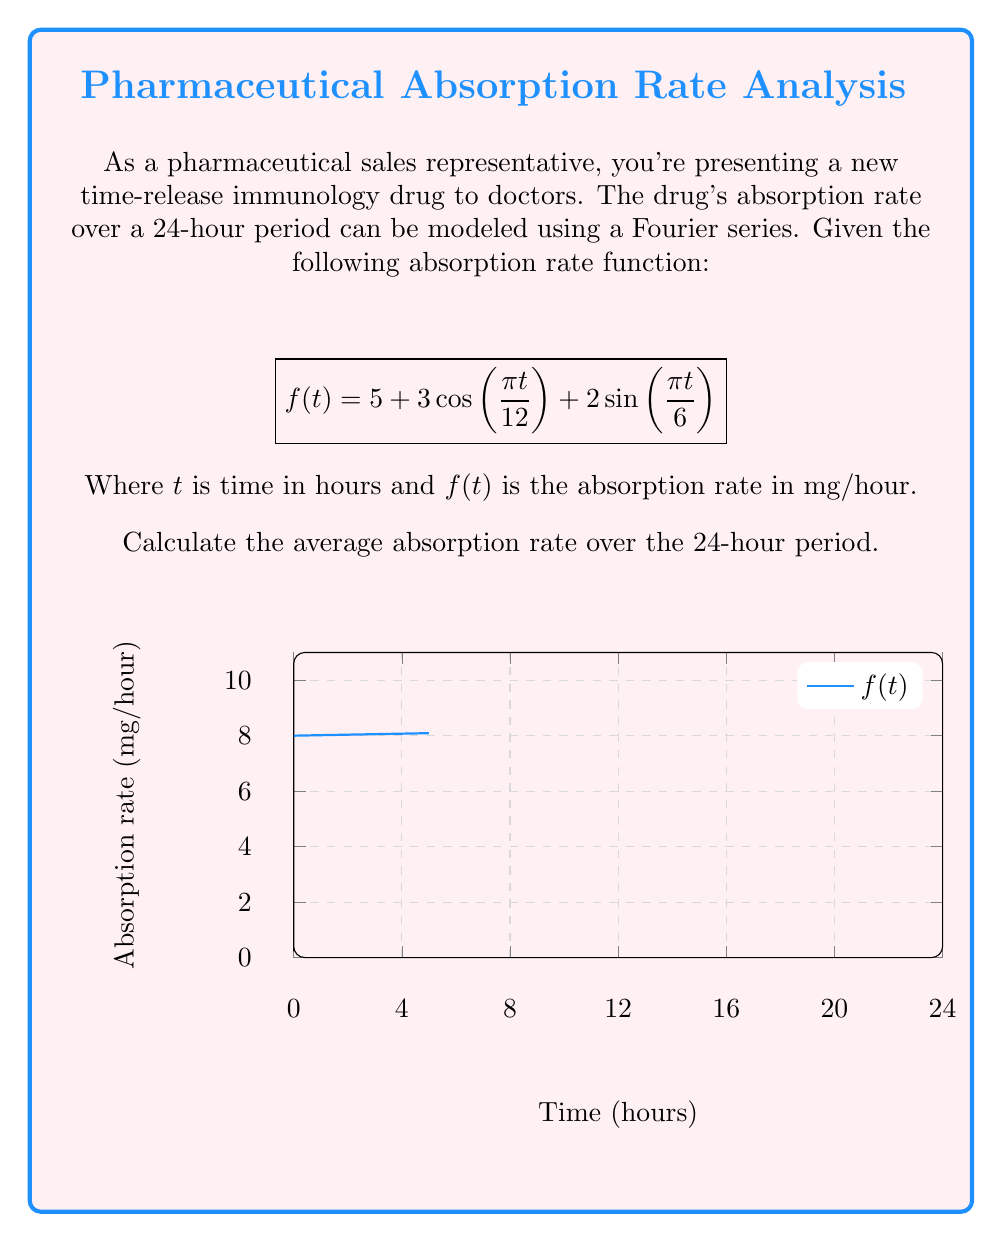Show me your answer to this math problem. To find the average absorption rate, we need to calculate the average value of the function over the 24-hour period. For a periodic function represented by a Fourier series, the average value is equal to the constant term (a₀) in the series.

Step 1: Identify the constant term in the given Fourier series.
The function is given as:
$$f(t) = 5 + 3\cos(\frac{\pi t}{12}) + 2\sin(\frac{\pi t}{6})$$
The constant term is 5.

Step 2: Verify that this is indeed the average value.
For a Fourier series, the average value over one period is:
$$\frac{1}{T}\int_0^T f(t)dt$$
where T is the period (in this case, 24 hours).

The cosine and sine terms integrate to zero over their full period, so:

$$\frac{1}{24}\int_0^{24} (5 + 3\cos(\frac{\pi t}{12}) + 2\sin(\frac{\pi t}{6}))dt = \frac{1}{24}\int_0^{24} 5dt = 5$$

Step 3: Conclude that the average absorption rate is 5 mg/hour.
Answer: 5 mg/hour 